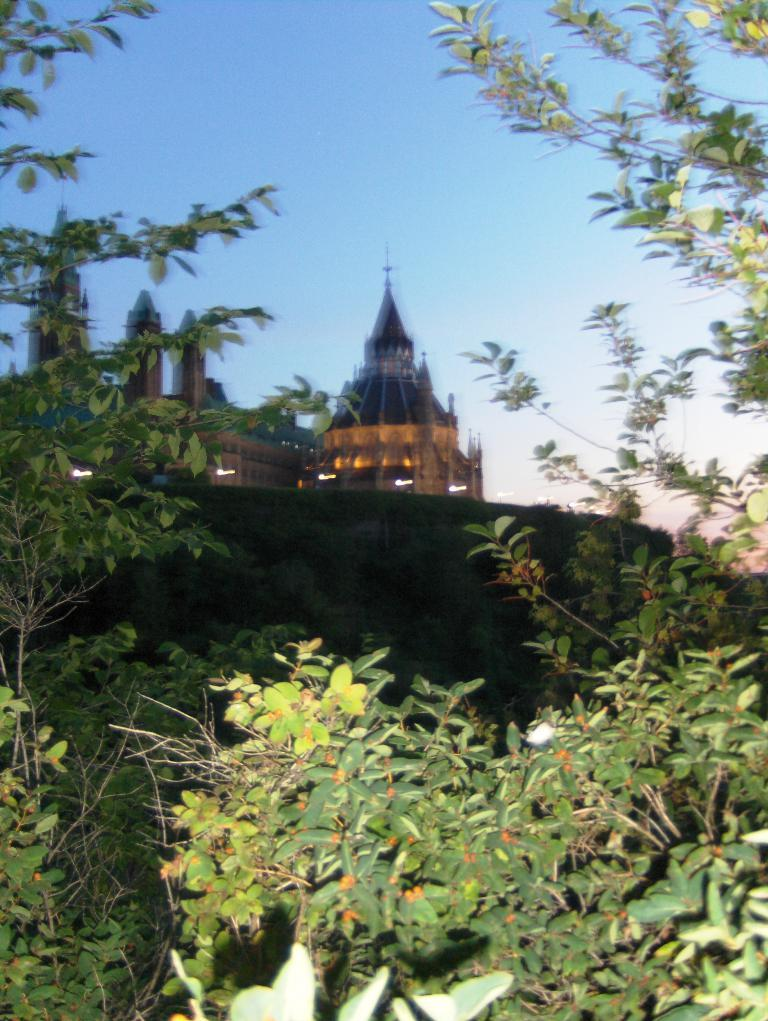What type of vegetation can be seen in the image? There are trees in the image. What can be seen in the background of the image? There is a building and a wall in the background of the image. What part of the natural environment is visible in the image? The sky is visible in the background of the image. What type of body is visible in the image? There is no body present in the image; it features trees, a building, a wall, and the sky. 